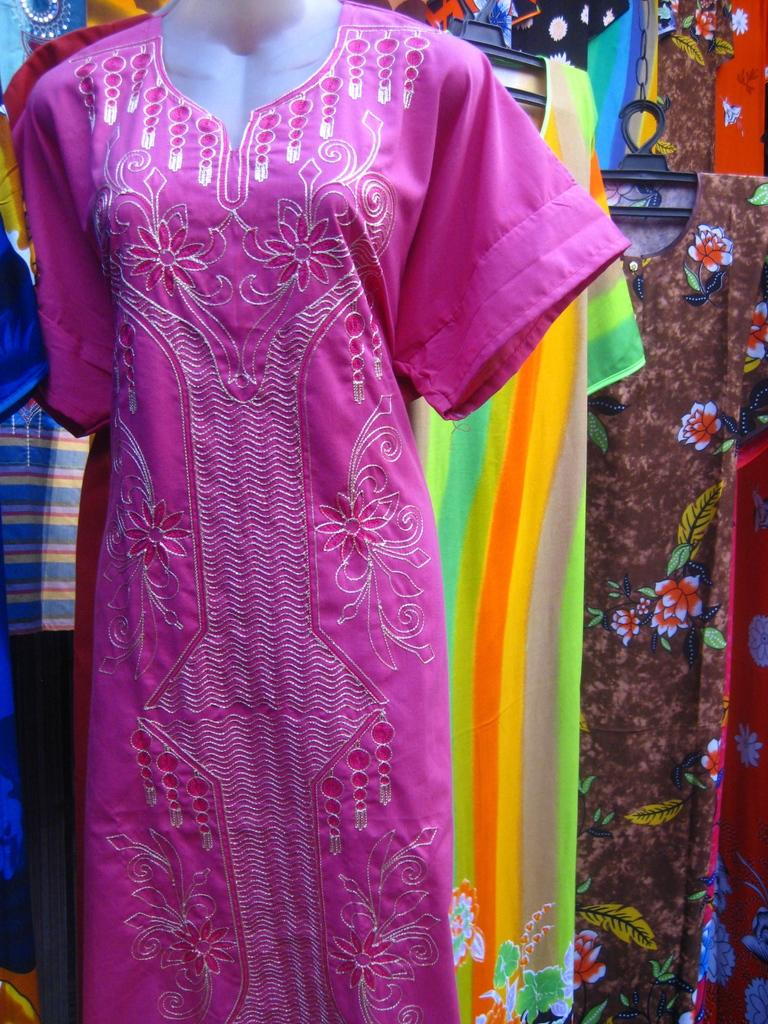What is on the mannequin in the image? There is a dress on a mannequin in the image. What can be seen in the background of the image? There are dresses on hangers in the background of the image. What type of lunch is being served in the image? There is no lunch present in the image; it features a dress on a mannequin and dresses on hangers in the background. How does the acoustics of the room affect the display of the dresses in the image? The image does not provide any information about the acoustics of the room, so it cannot be determined how they might affect the display of the dresses. 